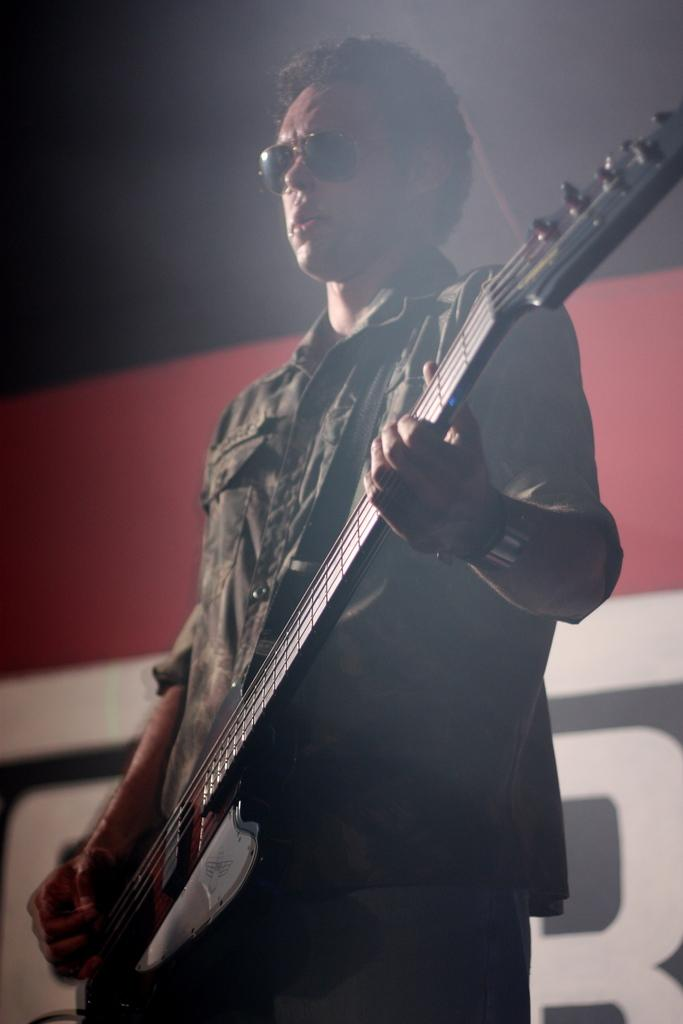What is the man in the image doing? The man is playing a guitar in the image. What type of protective eyewear is the man wearing? The man is wearing goggles in the image. What type of clothing is the man wearing on his upper body? The man is wearing a shirt in the image. What type of clothing is the man wearing on his lower body? The man is wearing trousers in the image. What can be seen in the background of the image? There is a wall in the background of the image, and there is text on the wall. What type of polish is the man applying to his guitar in the image? There is no indication in the image that the man is applying any polish to his guitar. 